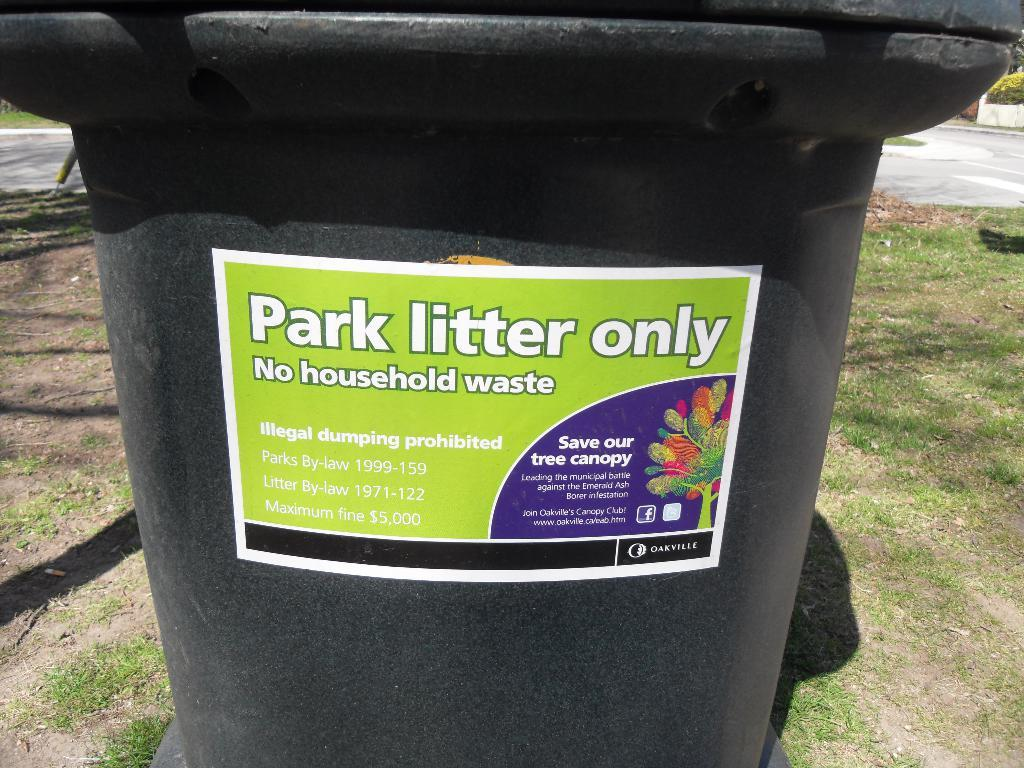<image>
Render a clear and concise summary of the photo. A rubbish bin which reads Park Litter only on the front. 